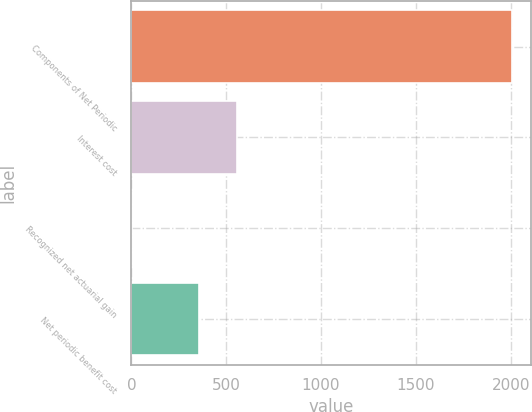Convert chart to OTSL. <chart><loc_0><loc_0><loc_500><loc_500><bar_chart><fcel>Components of Net Periodic<fcel>Interest cost<fcel>Recognized net actuarial gain<fcel>Net periodic benefit cost<nl><fcel>2006<fcel>554.5<fcel>1<fcel>354<nl></chart> 